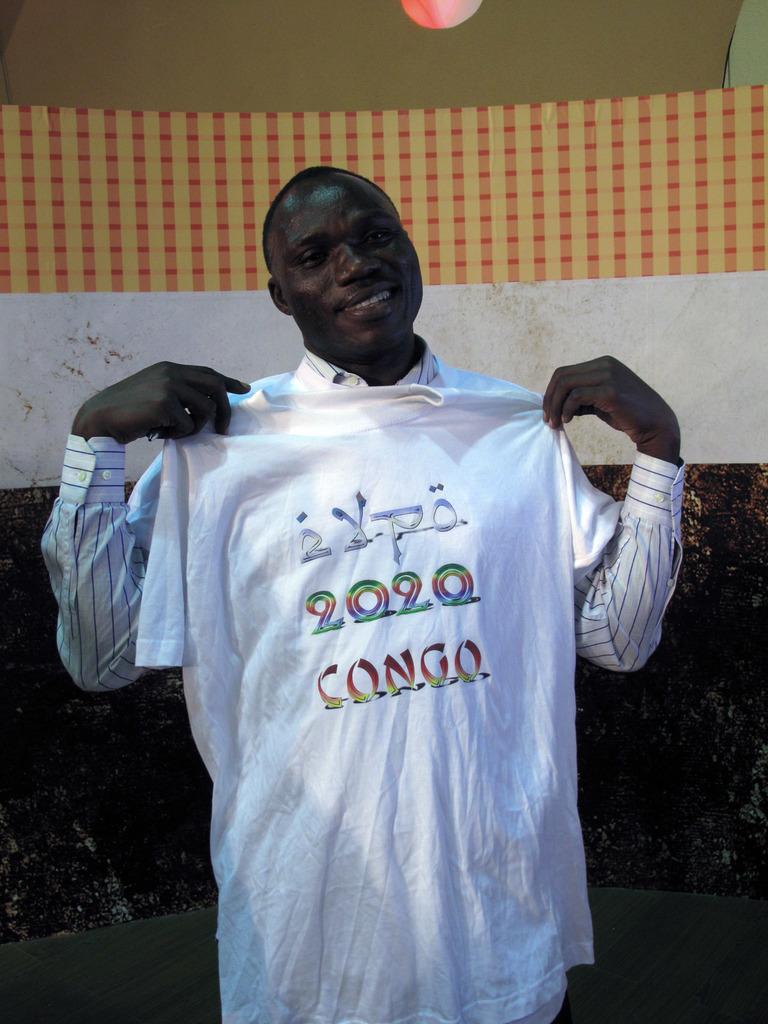Where does the event in 2020 take place?
Your response must be concise. Congo. What year is on the shirt?
Your answer should be compact. 2020. 